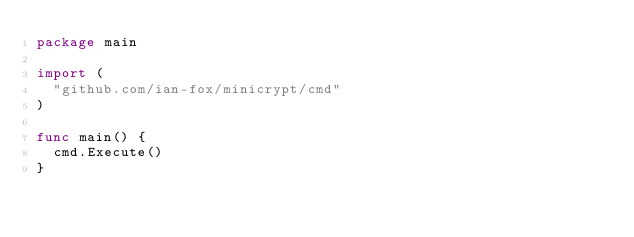Convert code to text. <code><loc_0><loc_0><loc_500><loc_500><_Go_>package main

import (
  "github.com/ian-fox/minicrypt/cmd"
)

func main() {
  cmd.Execute()
}
</code> 